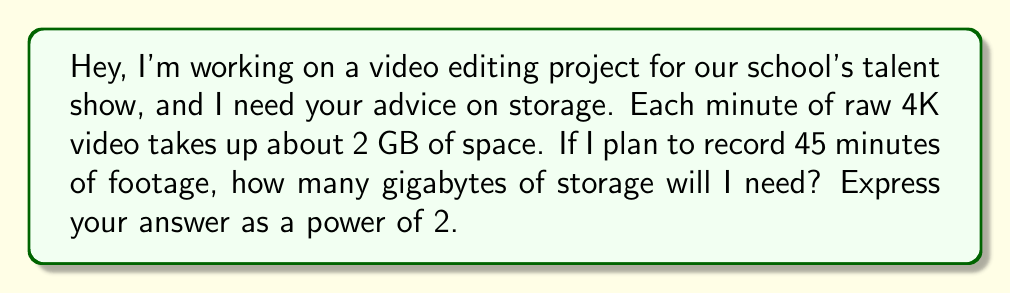Provide a solution to this math problem. Let's approach this step-by-step:

1) First, calculate the total storage needed in GB:
   $45 \text{ minutes} \times 2 \text{ GB/minute} = 90 \text{ GB}$

2) Now, we need to express 90 GB as a power of 2. In other words, we need to find $n$ where:
   $2^n = 90$

3) We can use logarithms to solve this:
   $\log_2(90) \approx 6.4919$

4) This means that $2^6 < 90 < 2^7$

5) Since we can't have fractional storage, we need to round up to the next power of 2. So we'll use $2^7$.

6) Let's verify:
   $2^7 = 128 \text{ GB}$

Therefore, you'll need $2^7 = 128$ GB of storage for your project.
Answer: $2^7 \text{ GB}$ 